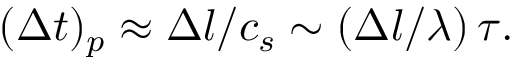<formula> <loc_0><loc_0><loc_500><loc_500>( { \Delta } t ) _ { p } \approx \Delta l / c _ { s } \sim ( \Delta l / \lambda ) \, \tau .</formula> 